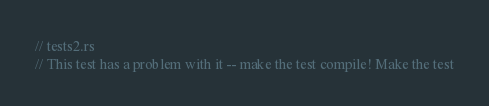Convert code to text. <code><loc_0><loc_0><loc_500><loc_500><_Rust_>// tests2.rs
// This test has a problem with it -- make the test compile! Make the test</code> 